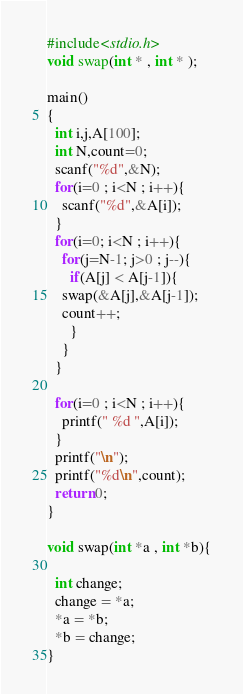<code> <loc_0><loc_0><loc_500><loc_500><_C_>#include<stdio.h>
void swap(int * , int * );

main()
{
  int i,j,A[100];
  int N,count=0;
  scanf("%d",&N);
  for(i=0 ; i<N ; i++){
    scanf("%d",&A[i]);
  }
  for(i=0; i<N ; i++){
    for(j=N-1; j>0 ; j--){
      if(A[j] < A[j-1]){
	swap(&A[j],&A[j-1]);
	count++;
      }
    }
  }
  
  for(i=0 ; i<N ; i++){
    printf(" %d ",A[i]);
  }
  printf("\n");
  printf("%d\n",count);
  return 0;
}

void swap(int *a , int *b){

  int change;
  change = *a;
  *a = *b;
  *b = change;
}</code> 